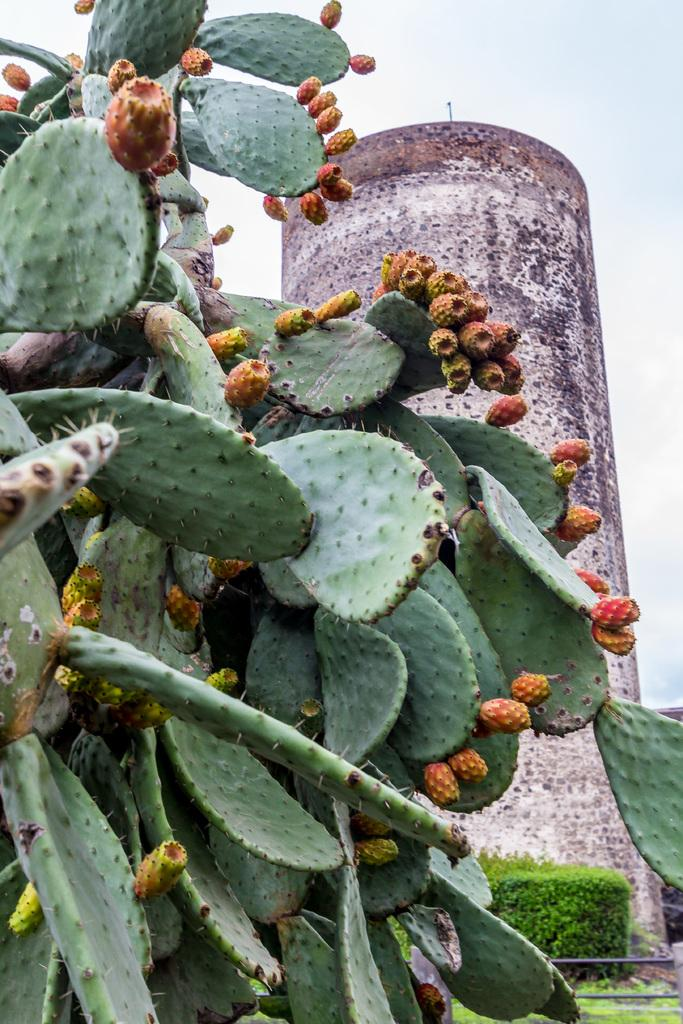What type of plant is in the image? There is a cactus plant in the image. What can be seen in the background of the image? There is a building visible in the background of the image. How many goldfish are swimming around the cactus plant in the image? There are no goldfish present in the image; it features a cactus plant and a building in the background. 